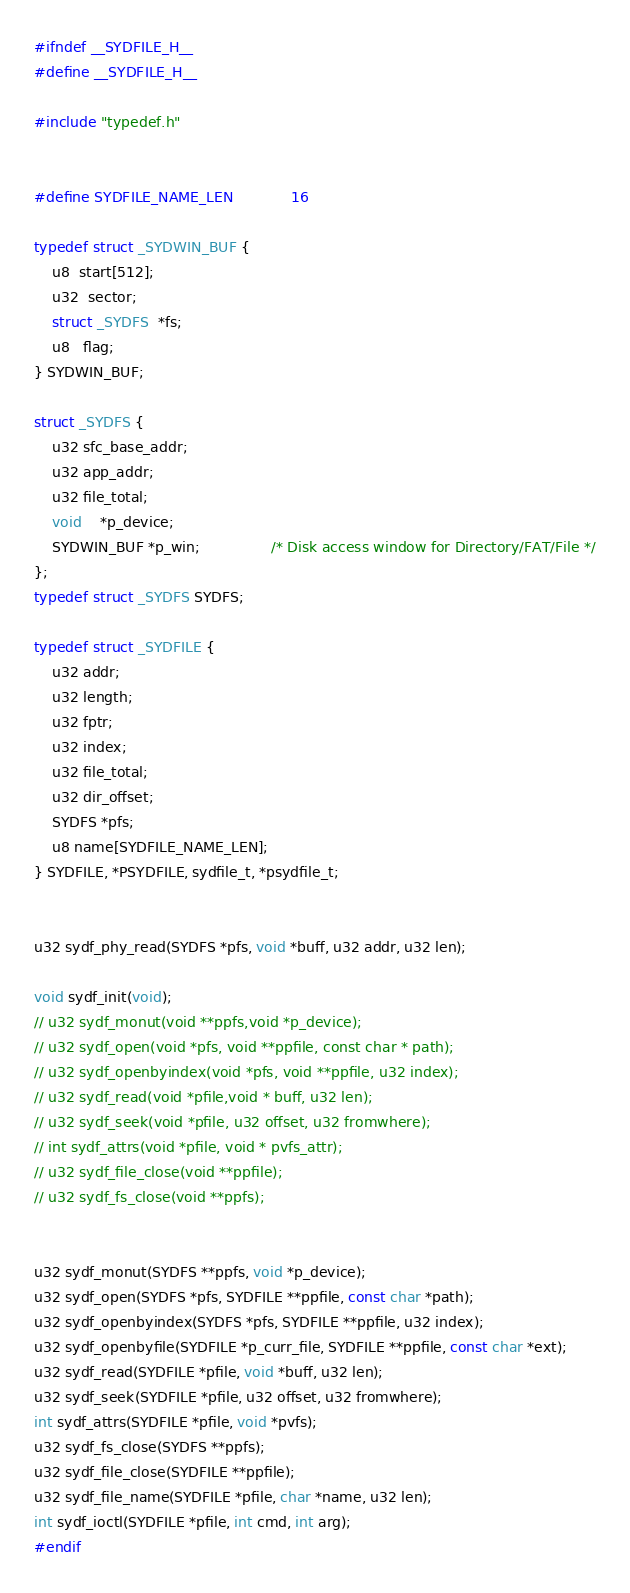Convert code to text. <code><loc_0><loc_0><loc_500><loc_500><_C_>#ifndef __SYDFILE_H__
#define __SYDFILE_H__

#include "typedef.h"


#define SYDFILE_NAME_LEN 			16

typedef struct _SYDWIN_BUF {
    u8  start[512];
    u32  sector;
    struct _SYDFS  *fs;
    u8   flag;
} SYDWIN_BUF;

struct _SYDFS {
    u32 sfc_base_addr;
    u32 app_addr;
    u32 file_total;
    void    *p_device;
    SYDWIN_BUF *p_win;                /* Disk access window for Directory/FAT/File */
};
typedef struct _SYDFS SYDFS;

typedef struct _SYDFILE {
    u32 addr;
    u32 length;
    u32 fptr;
    u32 index;
    u32 file_total;
    u32 dir_offset;
    SYDFS *pfs;
    u8 name[SYDFILE_NAME_LEN];
} SYDFILE, *PSYDFILE, sydfile_t, *psydfile_t;


u32 sydf_phy_read(SYDFS *pfs, void *buff, u32 addr, u32 len);

void sydf_init(void);
// u32 sydf_monut(void **ppfs,void *p_device);
// u32 sydf_open(void *pfs, void **ppfile, const char * path);
// u32 sydf_openbyindex(void *pfs, void **ppfile, u32 index);
// u32 sydf_read(void *pfile,void * buff, u32 len);
// u32 sydf_seek(void *pfile, u32 offset, u32 fromwhere);
// int sydf_attrs(void *pfile, void * pvfs_attr);
// u32 sydf_file_close(void **ppfile);
// u32 sydf_fs_close(void **ppfs);


u32 sydf_monut(SYDFS **ppfs, void *p_device);
u32 sydf_open(SYDFS *pfs, SYDFILE **ppfile, const char *path);
u32 sydf_openbyindex(SYDFS *pfs, SYDFILE **ppfile, u32 index);
u32 sydf_openbyfile(SYDFILE *p_curr_file, SYDFILE **ppfile, const char *ext);
u32 sydf_read(SYDFILE *pfile, void *buff, u32 len);
u32 sydf_seek(SYDFILE *pfile, u32 offset, u32 fromwhere);
int sydf_attrs(SYDFILE *pfile, void *pvfs);
u32 sydf_fs_close(SYDFS **ppfs);
u32 sydf_file_close(SYDFILE **ppfile);
u32 sydf_file_name(SYDFILE *pfile, char *name, u32 len);
int sydf_ioctl(SYDFILE *pfile, int cmd, int arg);
#endif
</code> 